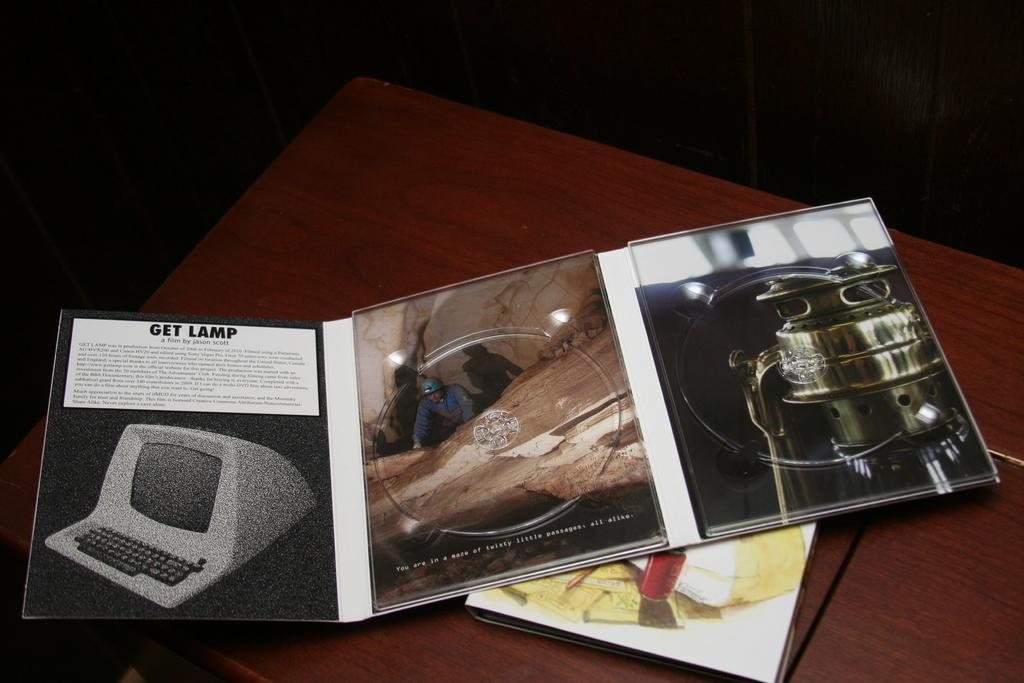What is present on the card in the image? The card has pictures on it. Where is the card located in the image? The card is placed on a wooden table. What can be seen at the top of the image? The top of the image has a dark view. What is the title of the book the person is reading in the image? There is no person or book present in the image; it only features a card on a wooden table with a dark view at the top. 